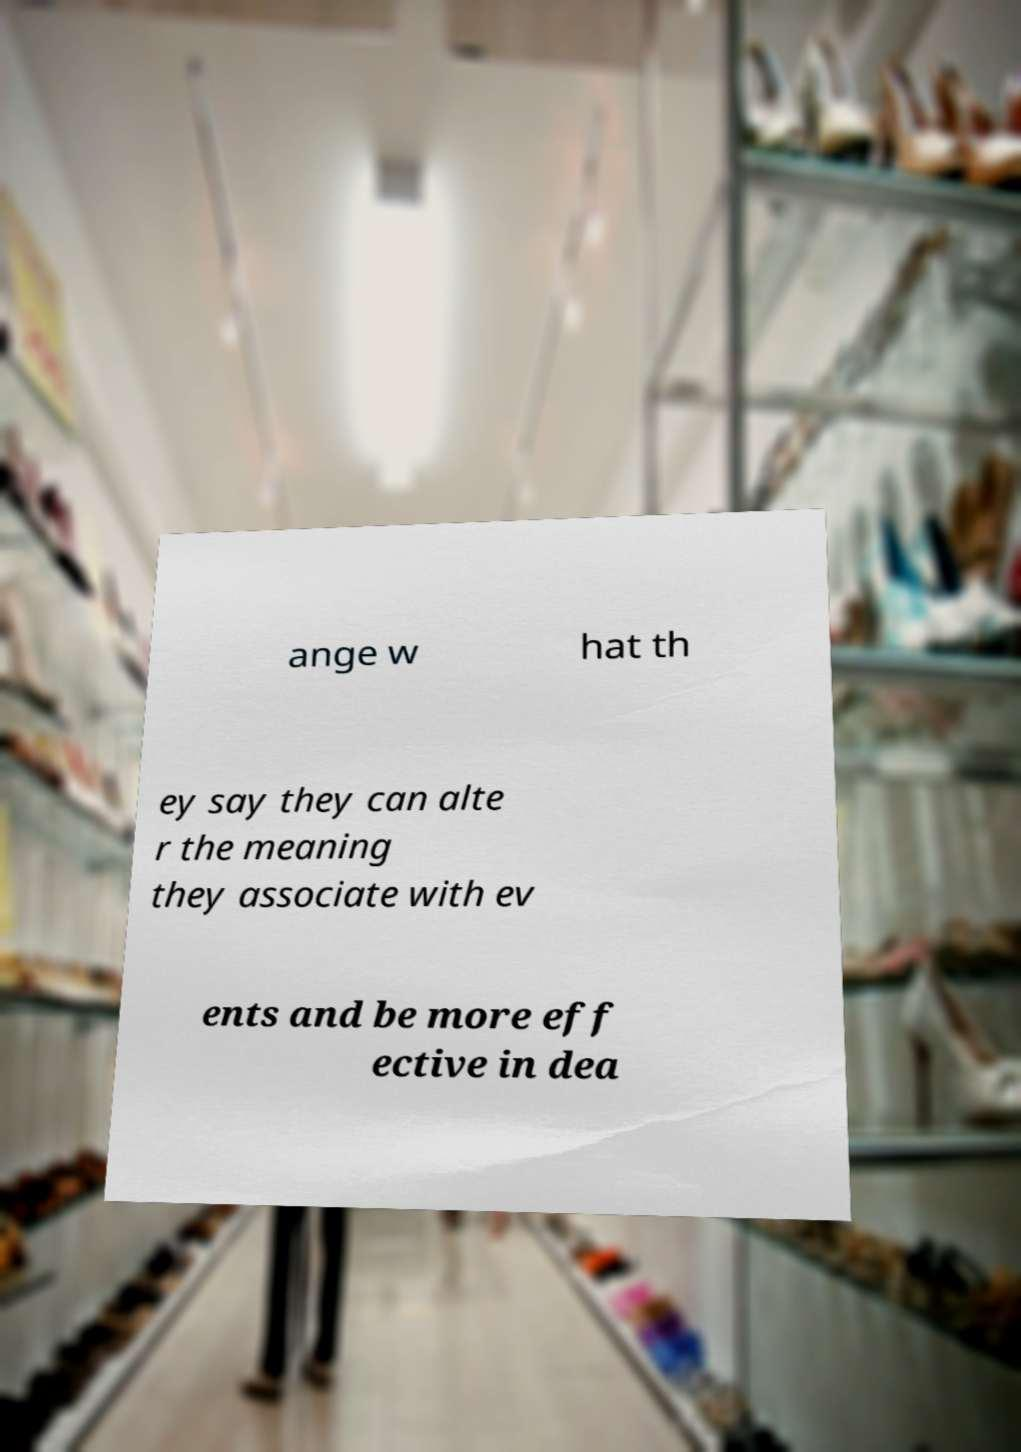Can you read and provide the text displayed in the image?This photo seems to have some interesting text. Can you extract and type it out for me? ange w hat th ey say they can alte r the meaning they associate with ev ents and be more eff ective in dea 